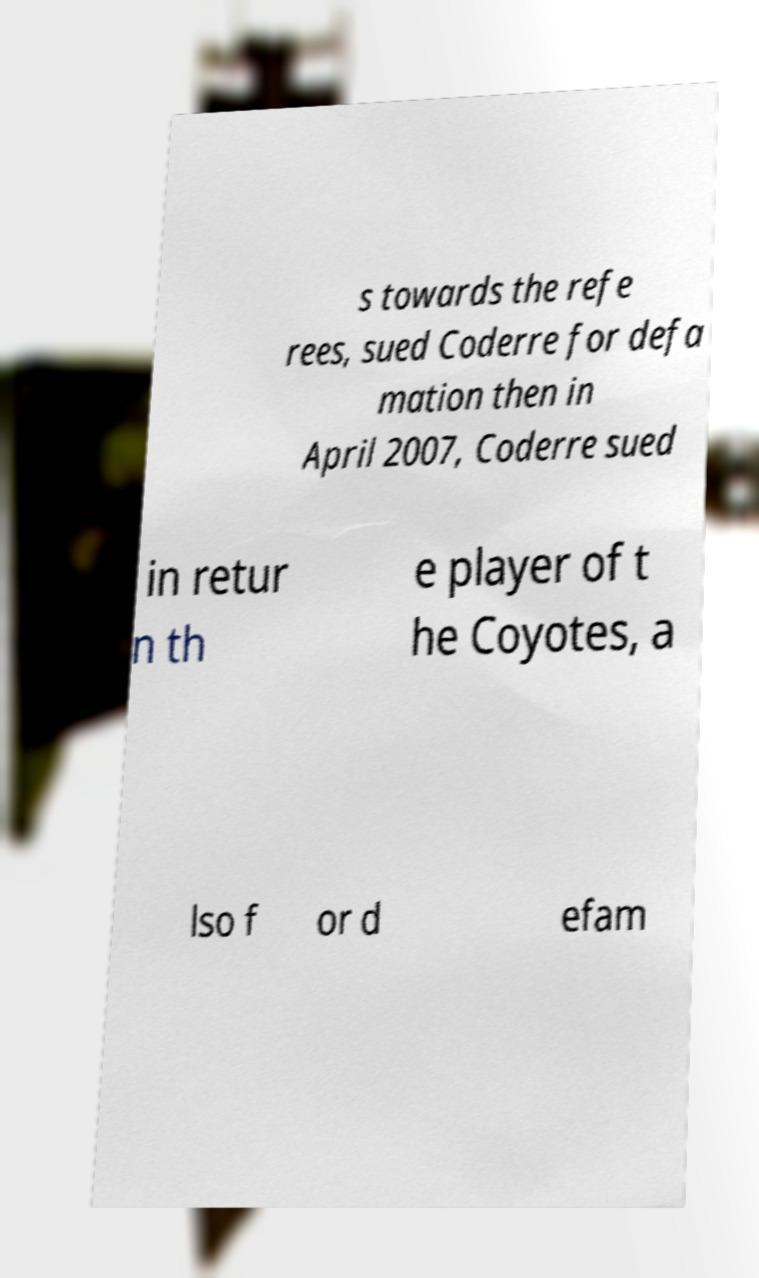Can you accurately transcribe the text from the provided image for me? s towards the refe rees, sued Coderre for defa mation then in April 2007, Coderre sued in retur n th e player of t he Coyotes, a lso f or d efam 